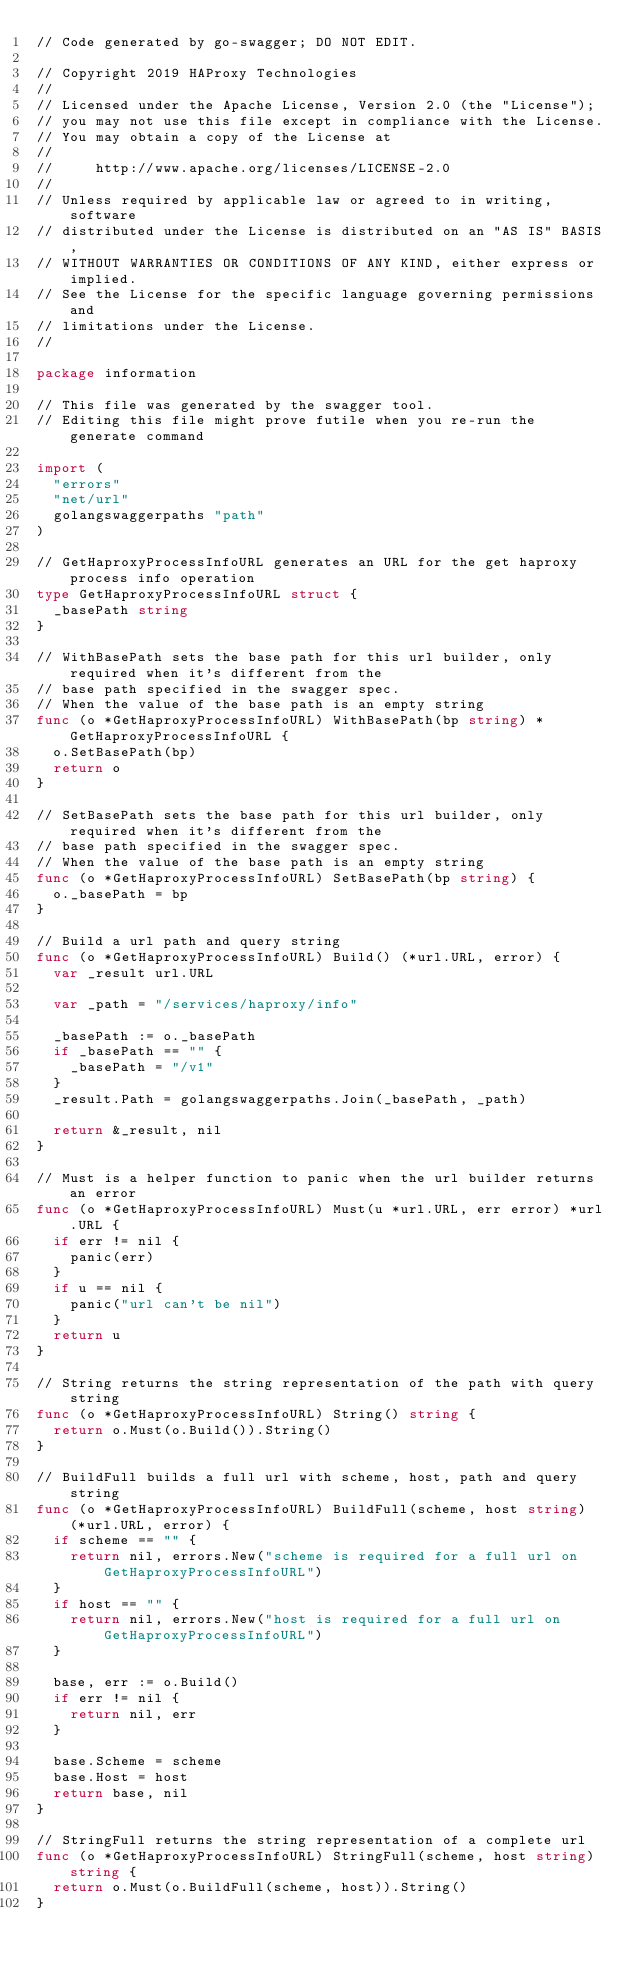<code> <loc_0><loc_0><loc_500><loc_500><_Go_>// Code generated by go-swagger; DO NOT EDIT.

// Copyright 2019 HAProxy Technologies
//
// Licensed under the Apache License, Version 2.0 (the "License");
// you may not use this file except in compliance with the License.
// You may obtain a copy of the License at
//
//     http://www.apache.org/licenses/LICENSE-2.0
//
// Unless required by applicable law or agreed to in writing, software
// distributed under the License is distributed on an "AS IS" BASIS,
// WITHOUT WARRANTIES OR CONDITIONS OF ANY KIND, either express or implied.
// See the License for the specific language governing permissions and
// limitations under the License.
//

package information

// This file was generated by the swagger tool.
// Editing this file might prove futile when you re-run the generate command

import (
	"errors"
	"net/url"
	golangswaggerpaths "path"
)

// GetHaproxyProcessInfoURL generates an URL for the get haproxy process info operation
type GetHaproxyProcessInfoURL struct {
	_basePath string
}

// WithBasePath sets the base path for this url builder, only required when it's different from the
// base path specified in the swagger spec.
// When the value of the base path is an empty string
func (o *GetHaproxyProcessInfoURL) WithBasePath(bp string) *GetHaproxyProcessInfoURL {
	o.SetBasePath(bp)
	return o
}

// SetBasePath sets the base path for this url builder, only required when it's different from the
// base path specified in the swagger spec.
// When the value of the base path is an empty string
func (o *GetHaproxyProcessInfoURL) SetBasePath(bp string) {
	o._basePath = bp
}

// Build a url path and query string
func (o *GetHaproxyProcessInfoURL) Build() (*url.URL, error) {
	var _result url.URL

	var _path = "/services/haproxy/info"

	_basePath := o._basePath
	if _basePath == "" {
		_basePath = "/v1"
	}
	_result.Path = golangswaggerpaths.Join(_basePath, _path)

	return &_result, nil
}

// Must is a helper function to panic when the url builder returns an error
func (o *GetHaproxyProcessInfoURL) Must(u *url.URL, err error) *url.URL {
	if err != nil {
		panic(err)
	}
	if u == nil {
		panic("url can't be nil")
	}
	return u
}

// String returns the string representation of the path with query string
func (o *GetHaproxyProcessInfoURL) String() string {
	return o.Must(o.Build()).String()
}

// BuildFull builds a full url with scheme, host, path and query string
func (o *GetHaproxyProcessInfoURL) BuildFull(scheme, host string) (*url.URL, error) {
	if scheme == "" {
		return nil, errors.New("scheme is required for a full url on GetHaproxyProcessInfoURL")
	}
	if host == "" {
		return nil, errors.New("host is required for a full url on GetHaproxyProcessInfoURL")
	}

	base, err := o.Build()
	if err != nil {
		return nil, err
	}

	base.Scheme = scheme
	base.Host = host
	return base, nil
}

// StringFull returns the string representation of a complete url
func (o *GetHaproxyProcessInfoURL) StringFull(scheme, host string) string {
	return o.Must(o.BuildFull(scheme, host)).String()
}
</code> 